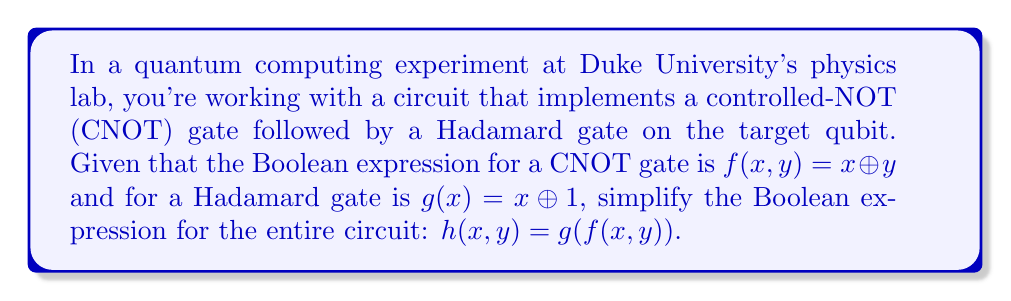Solve this math problem. Let's approach this step-by-step:

1) First, we need to understand what each gate does:
   CNOT gate: $f(x,y) = x \oplus y$
   Hadamard gate: $g(x) = x \oplus 1$

2) The circuit applies the CNOT gate first, then the Hadamard gate on the result of the CNOT. This is represented by $h(x,y) = g(f(x,y))$.

3) Let's substitute the expression for $f(x,y)$ into $g$:
   $h(x,y) = g(x \oplus y)$

4) Now, we can substitute the expression for $g$:
   $h(x,y) = (x \oplus y) \oplus 1$

5) In Boolean algebra, the XOR operation ($\oplus$) is associative, so we can rewrite this as:
   $h(x,y) = x \oplus y \oplus 1$

This is the simplified Boolean expression for the entire circuit.
Answer: $x \oplus y \oplus 1$ 